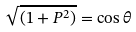<formula> <loc_0><loc_0><loc_500><loc_500>\sqrt { ( 1 + P ^ { 2 } ) } = \cos \theta</formula> 